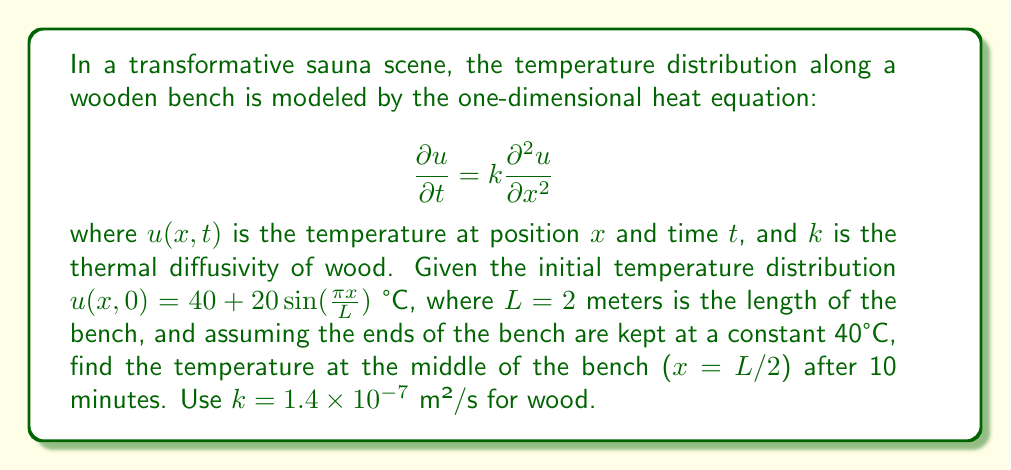Help me with this question. To solve this problem, we'll follow these steps:

1) The general solution to the heat equation with the given boundary conditions is:

   $$u(x,t) = 40 + \sum_{n=1}^{\infty} B_n \sin(\frac{n\pi x}{L}) e^{-k(\frac{n\pi}{L})^2t}$$

2) We need to find $B_n$ that matches our initial condition:

   $$40 + 20\sin(\frac{\pi x}{L}) = 40 + \sum_{n=1}^{\infty} B_n \sin(\frac{n\pi x}{L})$$

3) By comparing coefficients, we see that $B_1 = 20$ and $B_n = 0$ for $n > 1$.

4) Therefore, our solution simplifies to:

   $$u(x,t) = 40 + 20\sin(\frac{\pi x}{L}) e^{-k(\frac{\pi}{L})^2t}$$

5) We want to find $u(L/2, 600)$ as 10 minutes = 600 seconds:

   $$u(L/2, 600) = 40 + 20\sin(\frac{\pi (L/2)}{L}) e^{-k(\frac{\pi}{L})^2(600)}$$

6) Simplify:
   $$u(L/2, 600) = 40 + 20\sin(\frac{\pi}{2}) e^{-k(\frac{\pi}{L})^2(600)}$$
   $$= 40 + 20 e^{-k(\frac{\pi}{L})^2(600)}$$

7) Substitute known values:
   $$= 40 + 20 e^{-(1.4 \times 10^{-7})(\frac{\pi}{2})^2(600)}$$
   $$\approx 40 + 20 e^{-0.0659} \approx 58.72$$

Therefore, the temperature at the middle of the bench after 10 minutes is approximately 58.72°C.
Answer: 58.72°C 